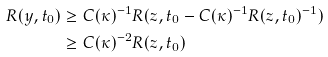Convert formula to latex. <formula><loc_0><loc_0><loc_500><loc_500>R ( y , t _ { 0 } ) & \geq C ( \kappa ) ^ { - 1 } R ( z , t _ { 0 } - C ( \kappa ) ^ { - 1 } R ( z , t _ { 0 } ) ^ { - 1 } ) \\ & \geq C ( \kappa ) ^ { - 2 } R ( z , t _ { 0 } )</formula> 